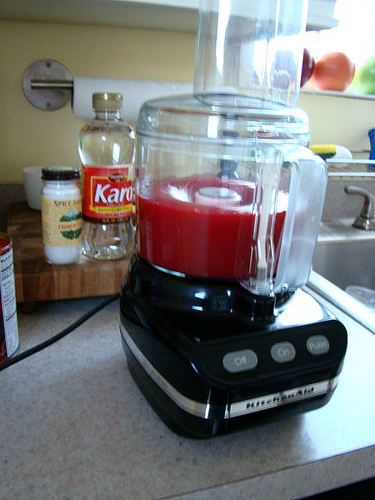Please transcribe the text information in this image. Karo 